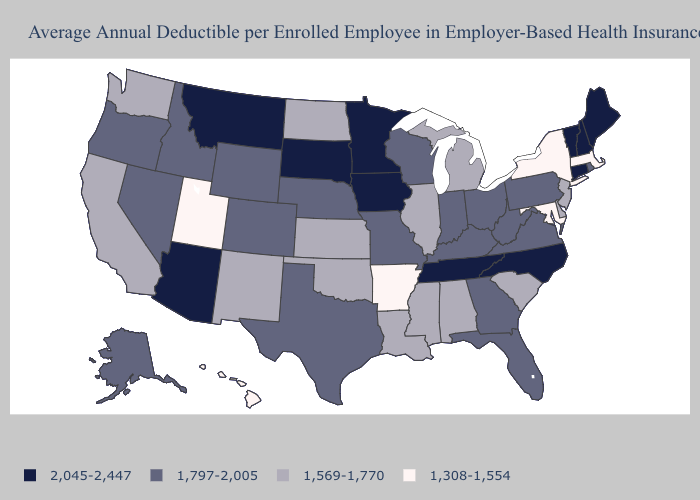What is the lowest value in states that border Michigan?
Write a very short answer. 1,797-2,005. Which states have the lowest value in the South?
Be succinct. Arkansas, Maryland. Name the states that have a value in the range 1,569-1,770?
Write a very short answer. Alabama, California, Delaware, Illinois, Kansas, Louisiana, Michigan, Mississippi, New Jersey, New Mexico, North Dakota, Oklahoma, South Carolina, Washington. Name the states that have a value in the range 1,308-1,554?
Concise answer only. Arkansas, Hawaii, Maryland, Massachusetts, New York, Utah. What is the highest value in the USA?
Write a very short answer. 2,045-2,447. Name the states that have a value in the range 1,797-2,005?
Give a very brief answer. Alaska, Colorado, Florida, Georgia, Idaho, Indiana, Kentucky, Missouri, Nebraska, Nevada, Ohio, Oregon, Pennsylvania, Rhode Island, Texas, Virginia, West Virginia, Wisconsin, Wyoming. What is the value of Utah?
Give a very brief answer. 1,308-1,554. What is the value of Minnesota?
Quick response, please. 2,045-2,447. Does Michigan have the highest value in the USA?
Keep it brief. No. Name the states that have a value in the range 1,308-1,554?
Answer briefly. Arkansas, Hawaii, Maryland, Massachusetts, New York, Utah. Is the legend a continuous bar?
Answer briefly. No. Among the states that border Montana , which have the highest value?
Write a very short answer. South Dakota. Name the states that have a value in the range 1,308-1,554?
Concise answer only. Arkansas, Hawaii, Maryland, Massachusetts, New York, Utah. Does the first symbol in the legend represent the smallest category?
Keep it brief. No. What is the lowest value in states that border Georgia?
Be succinct. 1,569-1,770. 